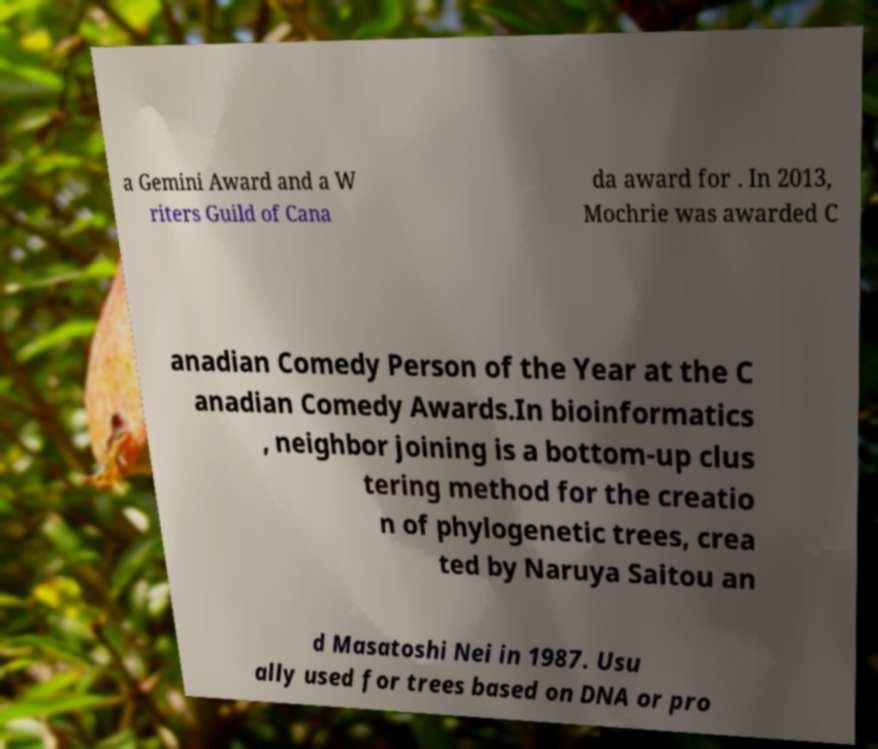I need the written content from this picture converted into text. Can you do that? a Gemini Award and a W riters Guild of Cana da award for . In 2013, Mochrie was awarded C anadian Comedy Person of the Year at the C anadian Comedy Awards.In bioinformatics , neighbor joining is a bottom-up clus tering method for the creatio n of phylogenetic trees, crea ted by Naruya Saitou an d Masatoshi Nei in 1987. Usu ally used for trees based on DNA or pro 